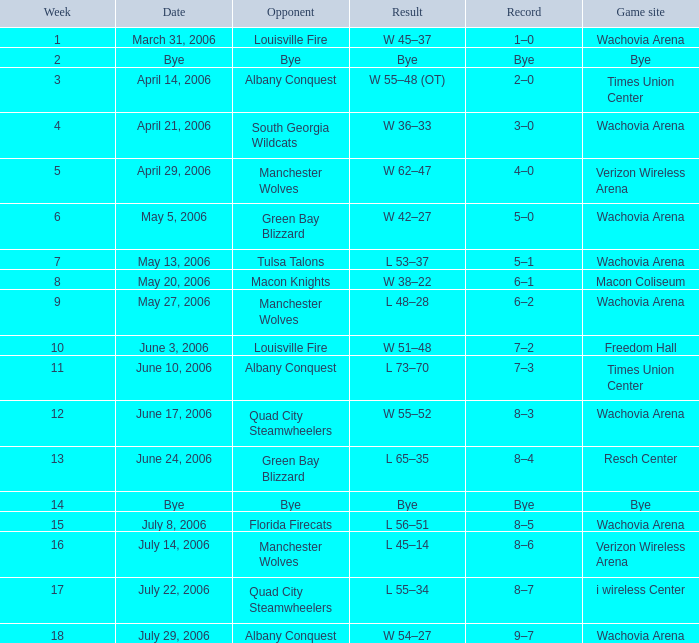Which team was the adversary during a week before 17 on june 17, 2006? Quad City Steamwheelers. 